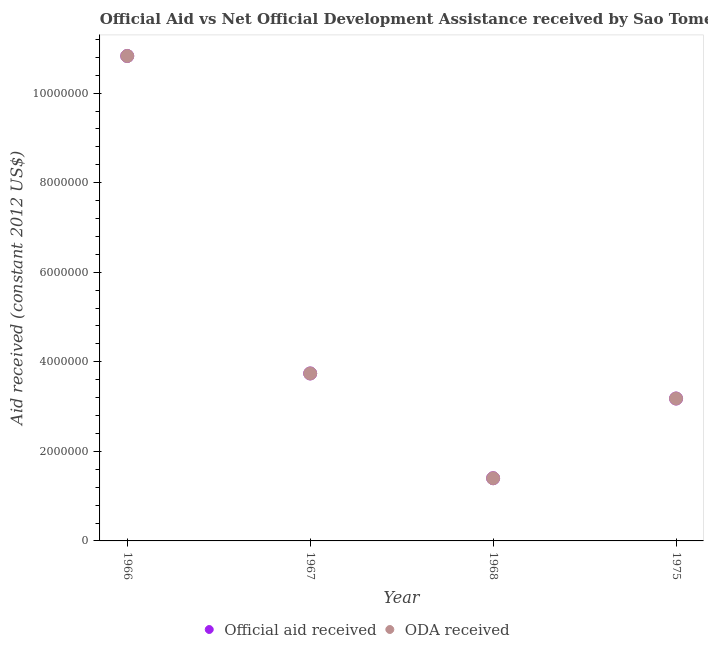What is the oda received in 1967?
Offer a very short reply. 3.74e+06. Across all years, what is the maximum oda received?
Offer a very short reply. 1.08e+07. Across all years, what is the minimum oda received?
Make the answer very short. 1.40e+06. In which year was the official aid received maximum?
Give a very brief answer. 1966. In which year was the oda received minimum?
Your answer should be very brief. 1968. What is the total oda received in the graph?
Keep it short and to the point. 1.92e+07. What is the difference between the official aid received in 1966 and that in 1968?
Offer a very short reply. 9.43e+06. What is the difference between the oda received in 1975 and the official aid received in 1968?
Your answer should be compact. 1.78e+06. What is the average oda received per year?
Provide a succinct answer. 4.79e+06. In the year 1975, what is the difference between the official aid received and oda received?
Your response must be concise. 0. What is the ratio of the oda received in 1967 to that in 1968?
Offer a very short reply. 2.67. Is the difference between the oda received in 1967 and 1968 greater than the difference between the official aid received in 1967 and 1968?
Your response must be concise. No. What is the difference between the highest and the second highest oda received?
Your answer should be compact. 7.09e+06. What is the difference between the highest and the lowest oda received?
Your response must be concise. 9.43e+06. In how many years, is the oda received greater than the average oda received taken over all years?
Keep it short and to the point. 1. Does the oda received monotonically increase over the years?
Provide a succinct answer. No. How many dotlines are there?
Your answer should be very brief. 2. How many years are there in the graph?
Your answer should be very brief. 4. Where does the legend appear in the graph?
Your answer should be compact. Bottom center. How many legend labels are there?
Give a very brief answer. 2. How are the legend labels stacked?
Keep it short and to the point. Horizontal. What is the title of the graph?
Make the answer very short. Official Aid vs Net Official Development Assistance received by Sao Tome and Principe . What is the label or title of the Y-axis?
Your response must be concise. Aid received (constant 2012 US$). What is the Aid received (constant 2012 US$) in Official aid received in 1966?
Provide a short and direct response. 1.08e+07. What is the Aid received (constant 2012 US$) of ODA received in 1966?
Your answer should be compact. 1.08e+07. What is the Aid received (constant 2012 US$) of Official aid received in 1967?
Make the answer very short. 3.74e+06. What is the Aid received (constant 2012 US$) in ODA received in 1967?
Give a very brief answer. 3.74e+06. What is the Aid received (constant 2012 US$) of Official aid received in 1968?
Give a very brief answer. 1.40e+06. What is the Aid received (constant 2012 US$) of ODA received in 1968?
Your response must be concise. 1.40e+06. What is the Aid received (constant 2012 US$) in Official aid received in 1975?
Offer a very short reply. 3.18e+06. What is the Aid received (constant 2012 US$) in ODA received in 1975?
Your answer should be compact. 3.18e+06. Across all years, what is the maximum Aid received (constant 2012 US$) in Official aid received?
Provide a short and direct response. 1.08e+07. Across all years, what is the maximum Aid received (constant 2012 US$) in ODA received?
Provide a succinct answer. 1.08e+07. Across all years, what is the minimum Aid received (constant 2012 US$) in Official aid received?
Provide a short and direct response. 1.40e+06. Across all years, what is the minimum Aid received (constant 2012 US$) of ODA received?
Ensure brevity in your answer.  1.40e+06. What is the total Aid received (constant 2012 US$) of Official aid received in the graph?
Offer a very short reply. 1.92e+07. What is the total Aid received (constant 2012 US$) in ODA received in the graph?
Provide a succinct answer. 1.92e+07. What is the difference between the Aid received (constant 2012 US$) of Official aid received in 1966 and that in 1967?
Provide a succinct answer. 7.09e+06. What is the difference between the Aid received (constant 2012 US$) of ODA received in 1966 and that in 1967?
Your answer should be very brief. 7.09e+06. What is the difference between the Aid received (constant 2012 US$) in Official aid received in 1966 and that in 1968?
Offer a very short reply. 9.43e+06. What is the difference between the Aid received (constant 2012 US$) of ODA received in 1966 and that in 1968?
Offer a terse response. 9.43e+06. What is the difference between the Aid received (constant 2012 US$) in Official aid received in 1966 and that in 1975?
Offer a very short reply. 7.65e+06. What is the difference between the Aid received (constant 2012 US$) of ODA received in 1966 and that in 1975?
Ensure brevity in your answer.  7.65e+06. What is the difference between the Aid received (constant 2012 US$) in Official aid received in 1967 and that in 1968?
Provide a short and direct response. 2.34e+06. What is the difference between the Aid received (constant 2012 US$) in ODA received in 1967 and that in 1968?
Your answer should be compact. 2.34e+06. What is the difference between the Aid received (constant 2012 US$) in Official aid received in 1967 and that in 1975?
Make the answer very short. 5.60e+05. What is the difference between the Aid received (constant 2012 US$) in ODA received in 1967 and that in 1975?
Give a very brief answer. 5.60e+05. What is the difference between the Aid received (constant 2012 US$) of Official aid received in 1968 and that in 1975?
Make the answer very short. -1.78e+06. What is the difference between the Aid received (constant 2012 US$) in ODA received in 1968 and that in 1975?
Keep it short and to the point. -1.78e+06. What is the difference between the Aid received (constant 2012 US$) of Official aid received in 1966 and the Aid received (constant 2012 US$) of ODA received in 1967?
Make the answer very short. 7.09e+06. What is the difference between the Aid received (constant 2012 US$) in Official aid received in 1966 and the Aid received (constant 2012 US$) in ODA received in 1968?
Give a very brief answer. 9.43e+06. What is the difference between the Aid received (constant 2012 US$) of Official aid received in 1966 and the Aid received (constant 2012 US$) of ODA received in 1975?
Offer a very short reply. 7.65e+06. What is the difference between the Aid received (constant 2012 US$) of Official aid received in 1967 and the Aid received (constant 2012 US$) of ODA received in 1968?
Give a very brief answer. 2.34e+06. What is the difference between the Aid received (constant 2012 US$) in Official aid received in 1967 and the Aid received (constant 2012 US$) in ODA received in 1975?
Offer a very short reply. 5.60e+05. What is the difference between the Aid received (constant 2012 US$) of Official aid received in 1968 and the Aid received (constant 2012 US$) of ODA received in 1975?
Offer a terse response. -1.78e+06. What is the average Aid received (constant 2012 US$) of Official aid received per year?
Give a very brief answer. 4.79e+06. What is the average Aid received (constant 2012 US$) in ODA received per year?
Your answer should be very brief. 4.79e+06. In the year 1967, what is the difference between the Aid received (constant 2012 US$) of Official aid received and Aid received (constant 2012 US$) of ODA received?
Provide a short and direct response. 0. In the year 1975, what is the difference between the Aid received (constant 2012 US$) in Official aid received and Aid received (constant 2012 US$) in ODA received?
Offer a very short reply. 0. What is the ratio of the Aid received (constant 2012 US$) of Official aid received in 1966 to that in 1967?
Give a very brief answer. 2.9. What is the ratio of the Aid received (constant 2012 US$) in ODA received in 1966 to that in 1967?
Ensure brevity in your answer.  2.9. What is the ratio of the Aid received (constant 2012 US$) of Official aid received in 1966 to that in 1968?
Give a very brief answer. 7.74. What is the ratio of the Aid received (constant 2012 US$) in ODA received in 1966 to that in 1968?
Keep it short and to the point. 7.74. What is the ratio of the Aid received (constant 2012 US$) of Official aid received in 1966 to that in 1975?
Provide a succinct answer. 3.41. What is the ratio of the Aid received (constant 2012 US$) in ODA received in 1966 to that in 1975?
Provide a succinct answer. 3.41. What is the ratio of the Aid received (constant 2012 US$) of Official aid received in 1967 to that in 1968?
Keep it short and to the point. 2.67. What is the ratio of the Aid received (constant 2012 US$) of ODA received in 1967 to that in 1968?
Your answer should be compact. 2.67. What is the ratio of the Aid received (constant 2012 US$) in Official aid received in 1967 to that in 1975?
Provide a succinct answer. 1.18. What is the ratio of the Aid received (constant 2012 US$) of ODA received in 1967 to that in 1975?
Give a very brief answer. 1.18. What is the ratio of the Aid received (constant 2012 US$) in Official aid received in 1968 to that in 1975?
Your answer should be compact. 0.44. What is the ratio of the Aid received (constant 2012 US$) in ODA received in 1968 to that in 1975?
Make the answer very short. 0.44. What is the difference between the highest and the second highest Aid received (constant 2012 US$) in Official aid received?
Keep it short and to the point. 7.09e+06. What is the difference between the highest and the second highest Aid received (constant 2012 US$) of ODA received?
Offer a terse response. 7.09e+06. What is the difference between the highest and the lowest Aid received (constant 2012 US$) in Official aid received?
Offer a very short reply. 9.43e+06. What is the difference between the highest and the lowest Aid received (constant 2012 US$) in ODA received?
Ensure brevity in your answer.  9.43e+06. 